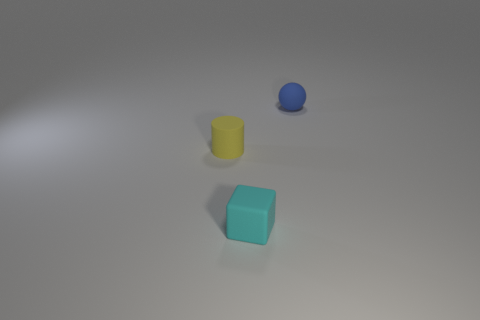Does the tiny object that is in front of the yellow matte thing have the same material as the tiny object on the right side of the small cyan matte thing? From the image, it appears that both objects, the small sphere in front of the yellow cylinder and the small sphere to the right of the cyan cube, have a similar smooth and shiny finish, suggesting that they could be made of a similar material, such as plastic or polished stone. 